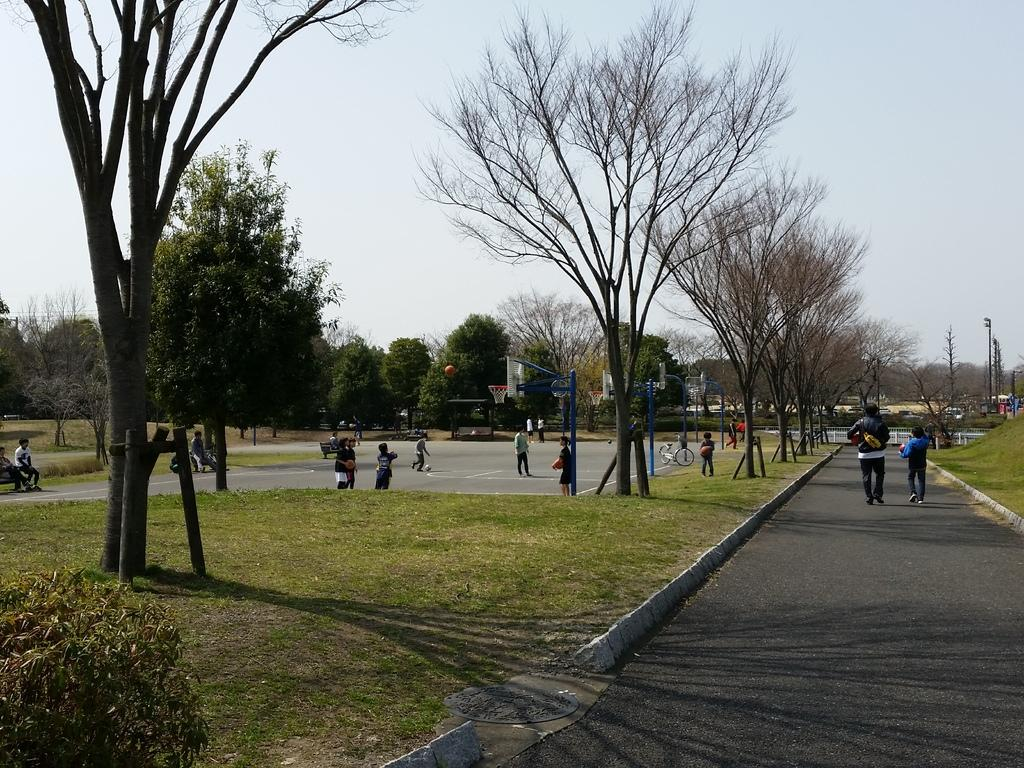What are the people in the image doing? The people in the image are walking on the road. What type of vegetation can be seen in the image? Grass, shrubs, and trees are visible in the image. What structures are present in the image? Poles are present in the image. What is visible in the background of the image? The sky is plain and visible in the background of the image. What type of pencil can be seen in the image? There is no pencil present in the image. Is the road level in the image? The facts provided do not mention the level of the road, so it cannot be determined from the image. 